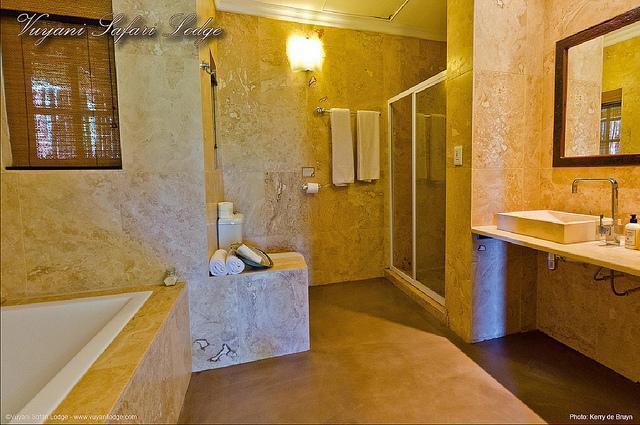What color is the lamp on the top of the wall next to the shower?
From the following four choices, select the correct answer to address the question.
Options: Yellow, blue, red, white. Yellow. 